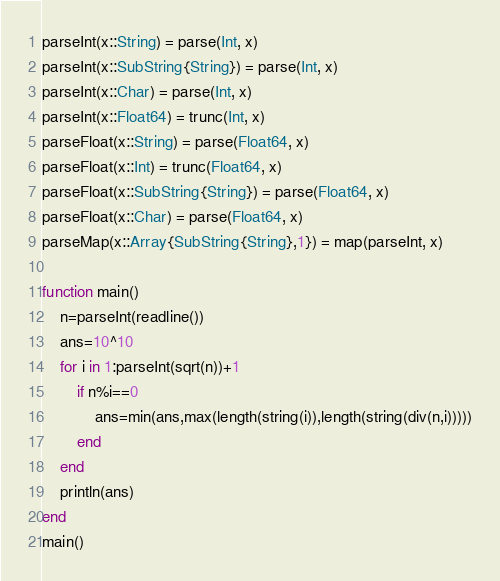Convert code to text. <code><loc_0><loc_0><loc_500><loc_500><_Julia_>parseInt(x::String) = parse(Int, x)
parseInt(x::SubString{String}) = parse(Int, x)
parseInt(x::Char) = parse(Int, x)
parseInt(x::Float64) = trunc(Int, x)
parseFloat(x::String) = parse(Float64, x)
parseFloat(x::Int) = trunc(Float64, x)
parseFloat(x::SubString{String}) = parse(Float64, x)
parseFloat(x::Char) = parse(Float64, x)
parseMap(x::Array{SubString{String},1}) = map(parseInt, x)

function main()
    n=parseInt(readline())
    ans=10^10
    for i in 1:parseInt(sqrt(n))+1
        if n%i==0
            ans=min(ans,max(length(string(i)),length(string(div(n,i)))))
        end
    end
    println(ans)
end
main()</code> 